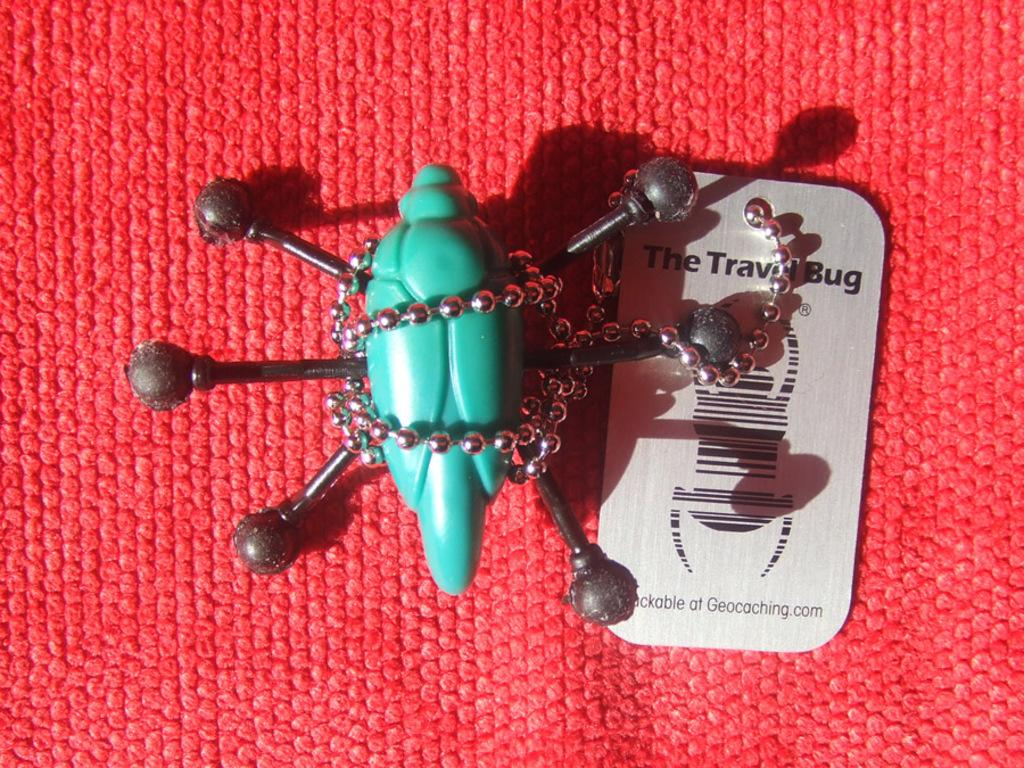What is the color of the object in the image? The object in the image has a green color. What is attached to the object in the image? There is a chain attached to the object in the image. Is there any information about the cost of the object in the image? Yes, there is a price tag in the image. What is the color of the surface in the image? The surface in the image has a red color. How many men are playing volleyball on the red surface in the image? There is no volleyball or men present in the image; it only features a green object with a chain, a price tag, and a red surface. 